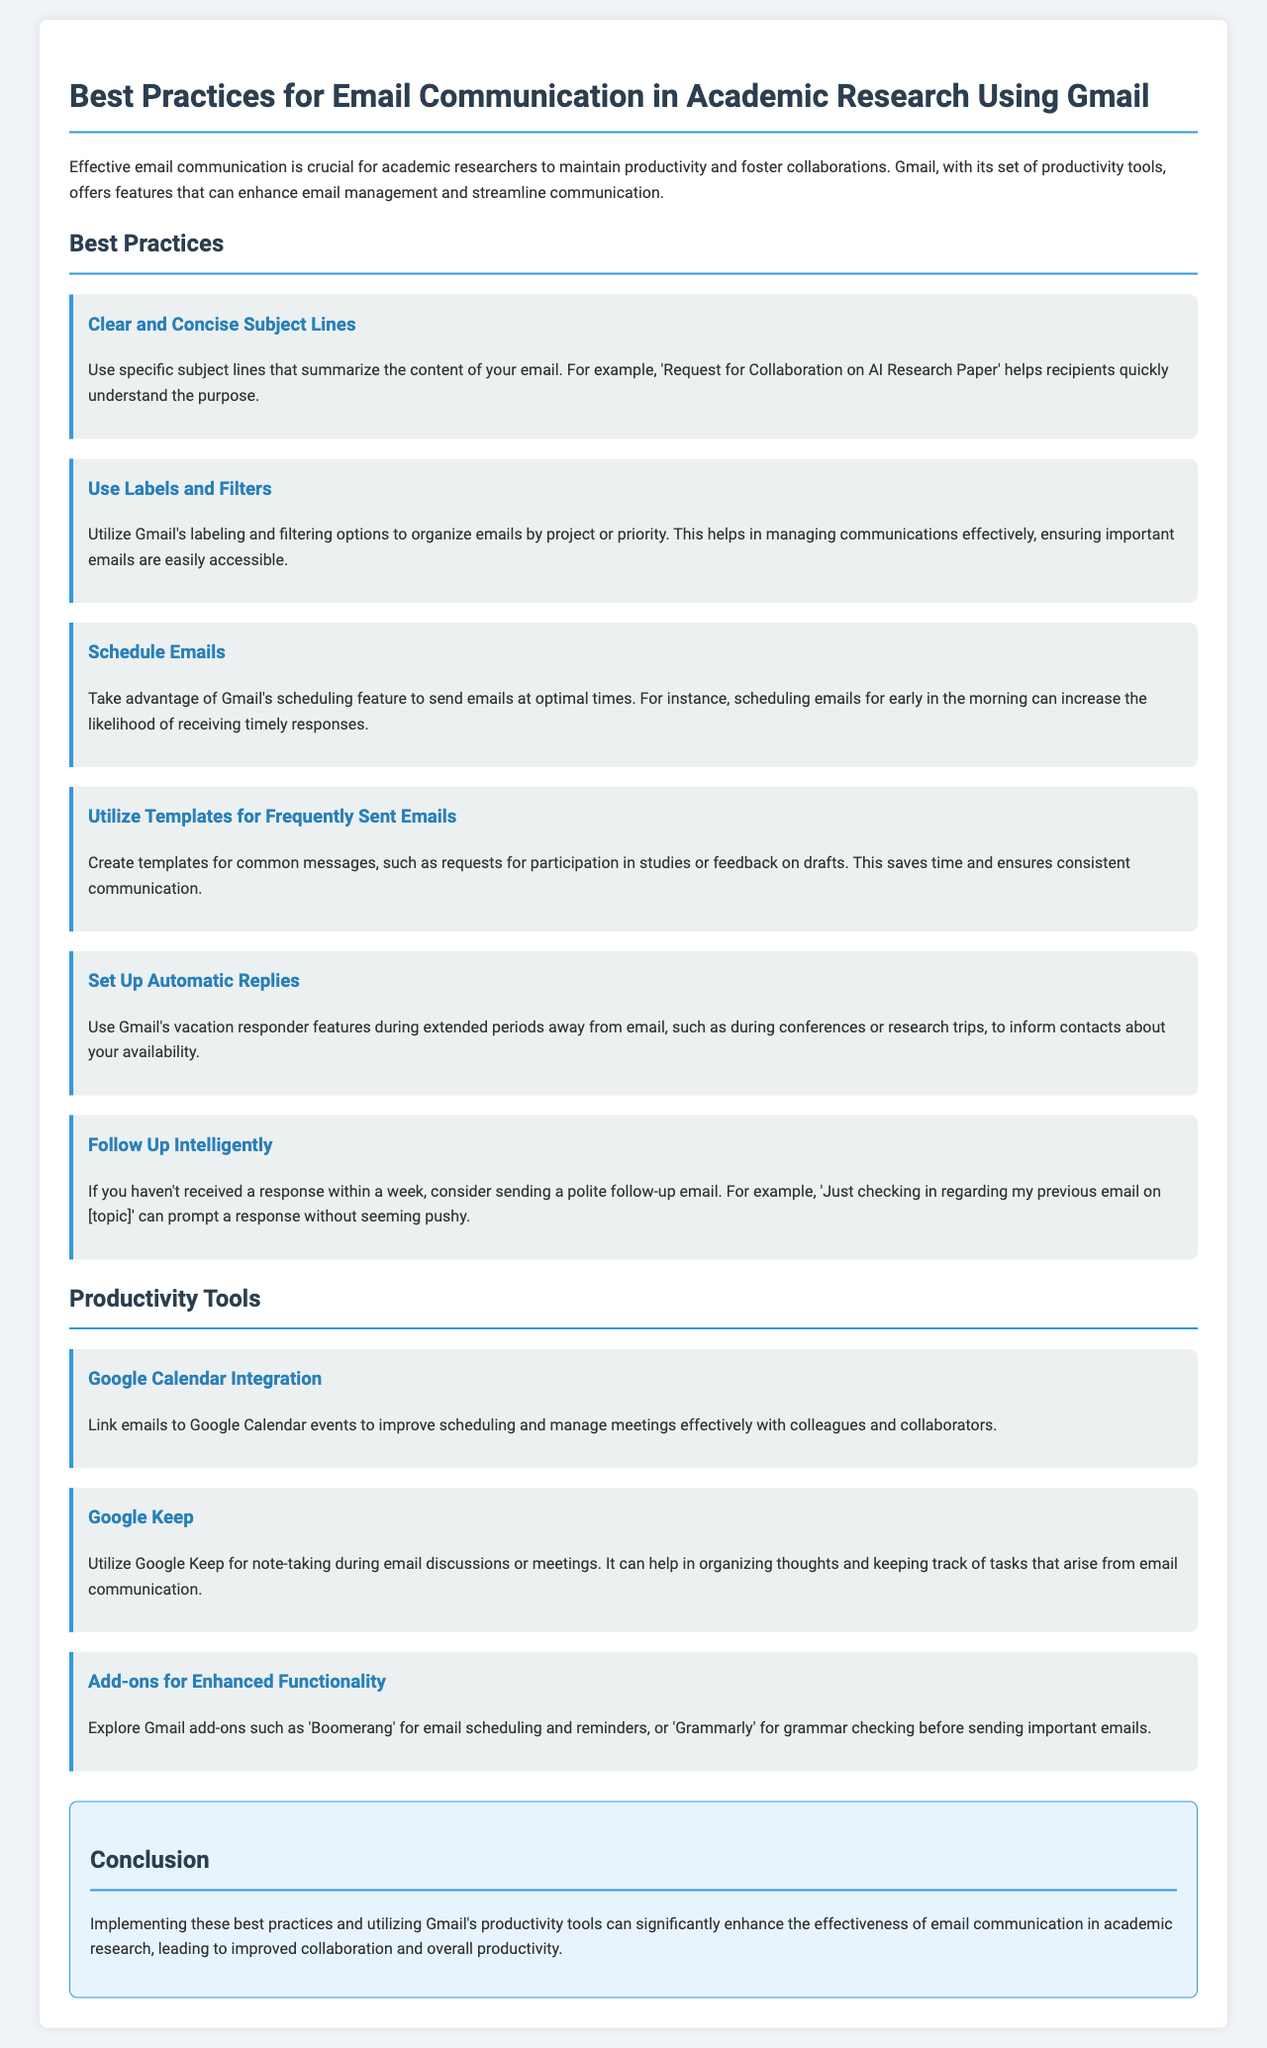What is the main topic of the document? The main topic of the document is about effective email communication in academic research using Gmail, as described in the introduction.
Answer: Email communication in academic research using Gmail How many best practices are listed in the document? The document outlines a total of six best practices for email communication.
Answer: Six What is one of the best practices for email communication mentioned? The document lists "Clear and Concise Subject Lines" as one of the best practices for effective email communication.
Answer: Clear and Concise Subject Lines What is a productivity tool mentioned in the document? One of the productivity tools mentioned in the document is "Google Keep," which is used for note-taking.
Answer: Google Keep What feature does Gmail offer for sending emails at optimal times? The document discusses the "scheduling feature" of Gmail that allows users to send emails at optimal times.
Answer: Scheduling feature What is the purpose of setting up automatic replies in Gmail? The document states that automatic replies inform contacts about your availability during periods when you cannot respond to emails.
Answer: Inform about availability Which add-on is suggested for email scheduling? The document recommends using "Boomerang" as an add-on for email scheduling and reminders.
Answer: Boomerang What is one way to follow up if a response has not been received? The document suggests sending a polite follow-up email after a week if no response has been received.
Answer: A polite follow-up email after a week 